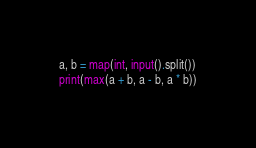Convert code to text. <code><loc_0><loc_0><loc_500><loc_500><_Python_>a, b = map(int, input().split())
print(max(a + b, a - b, a * b))</code> 